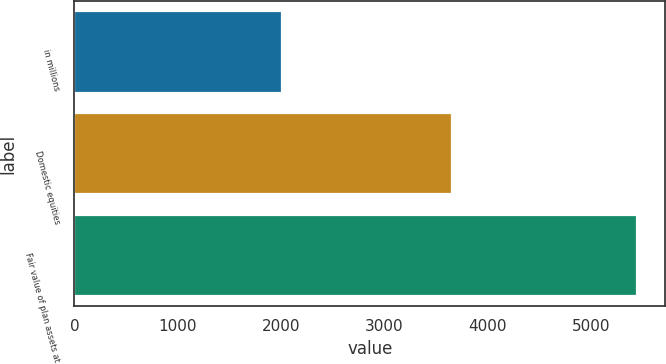<chart> <loc_0><loc_0><loc_500><loc_500><bar_chart><fcel>in millions<fcel>Domestic equities<fcel>Fair value of plan assets at<nl><fcel>2012<fcel>3657<fcel>5444<nl></chart> 